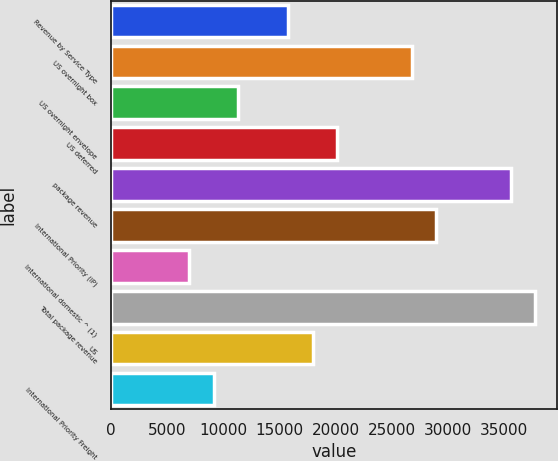<chart> <loc_0><loc_0><loc_500><loc_500><bar_chart><fcel>Revenue by Service Type<fcel>US overnight box<fcel>US overnight envelope<fcel>US deferred<fcel>package revenue<fcel>International Priority (IP)<fcel>International domestic ^ (1)<fcel>Total package revenue<fcel>US<fcel>International Priority Freight<nl><fcel>15746.6<fcel>26775.6<fcel>11335<fcel>20158.2<fcel>35598.8<fcel>28981.4<fcel>6923.4<fcel>37804.6<fcel>17952.4<fcel>9129.2<nl></chart> 